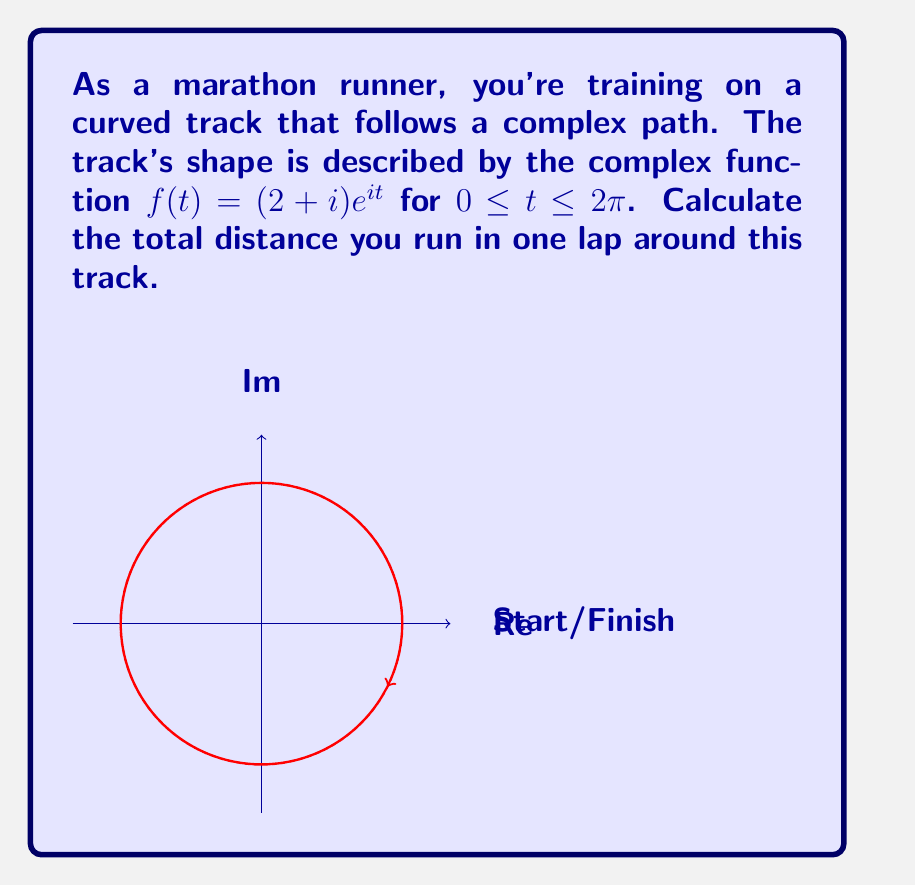Show me your answer to this math problem. Let's approach this step-by-step:

1) The distance traveled along a complex path is given by the line integral:

   $$\int_C |f'(t)| dt$$

   where $C$ is the path and $f'(t)$ is the derivative of the path function.

2) We need to find $f'(t)$:
   
   $$f'(t) = (2+i)ie^{it} = i(2+i)e^{it}$$

3) Calculate the magnitude of $f'(t)$:

   $$|f'(t)| = |i(2+i)e^{it}| = |2+i| \cdot |e^{it}| = \sqrt{2^2 + 1^2} \cdot 1 = \sqrt{5}$$

4) Now we can set up our integral:

   $$\text{Distance} = \int_0^{2\pi} |f'(t)| dt = \int_0^{2\pi} \sqrt{5} dt$$

5) Evaluate the integral:

   $$\int_0^{2\pi} \sqrt{5} dt = \sqrt{5} \cdot t \bigg|_0^{2\pi} = 2\pi\sqrt{5}$$

Thus, the total distance run in one lap is $2\pi\sqrt{5}$.
Answer: $2\pi\sqrt{5}$ 